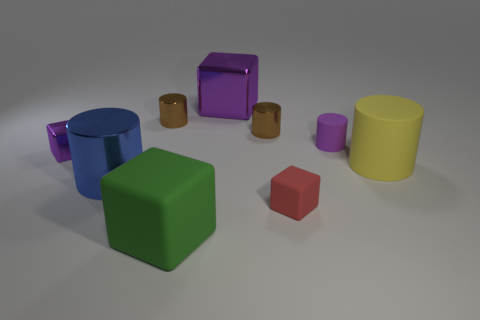Subtract 1 cylinders. How many cylinders are left? 4 Subtract all purple cylinders. How many cylinders are left? 4 Subtract all red cylinders. Subtract all green cubes. How many cylinders are left? 5 Add 1 big matte blocks. How many objects exist? 10 Subtract all cubes. How many objects are left? 5 Subtract 0 yellow spheres. How many objects are left? 9 Subtract all tiny brown metal cylinders. Subtract all green things. How many objects are left? 6 Add 6 small brown cylinders. How many small brown cylinders are left? 8 Add 9 large yellow metal cylinders. How many large yellow metal cylinders exist? 9 